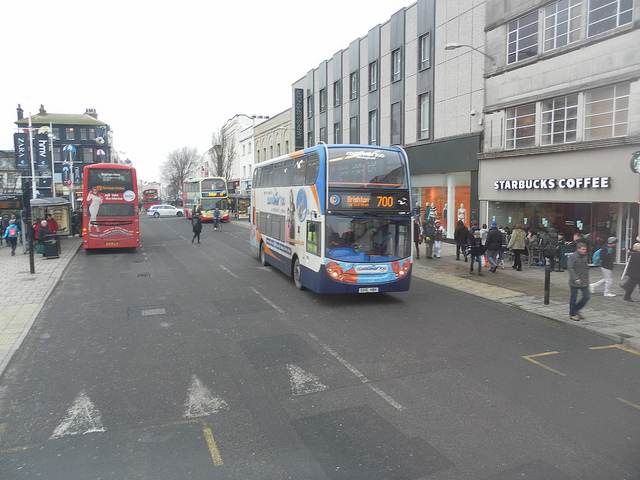What's happening in this scene? The scene depicts a typical urban street bustling with activity. In the foreground, a double-decker bus is prominently visible, likely operating on Route 700, as indicated. There are multiple other buses in the background, suggesting a hub of public transportation. Pedestrians are seen walking along the sidewalk, engaging with the numerous commercial establishments lining the street, including a noticeable Starbucks Coffee shop. The overall atmosphere is that of a busy cityscape, with elements of both vehicular and pedestrian traffic. Why do you think the headlights are on? The headlights of the buses might be on for a couple of reasons: it could be a safety measure, ensuring visibility during dawn or dusk, or during overcast conditions when natural light is insufficient. This practice helps in preventing accidents and ensuring the safety of both pedestrians and other vehicles on the road. 